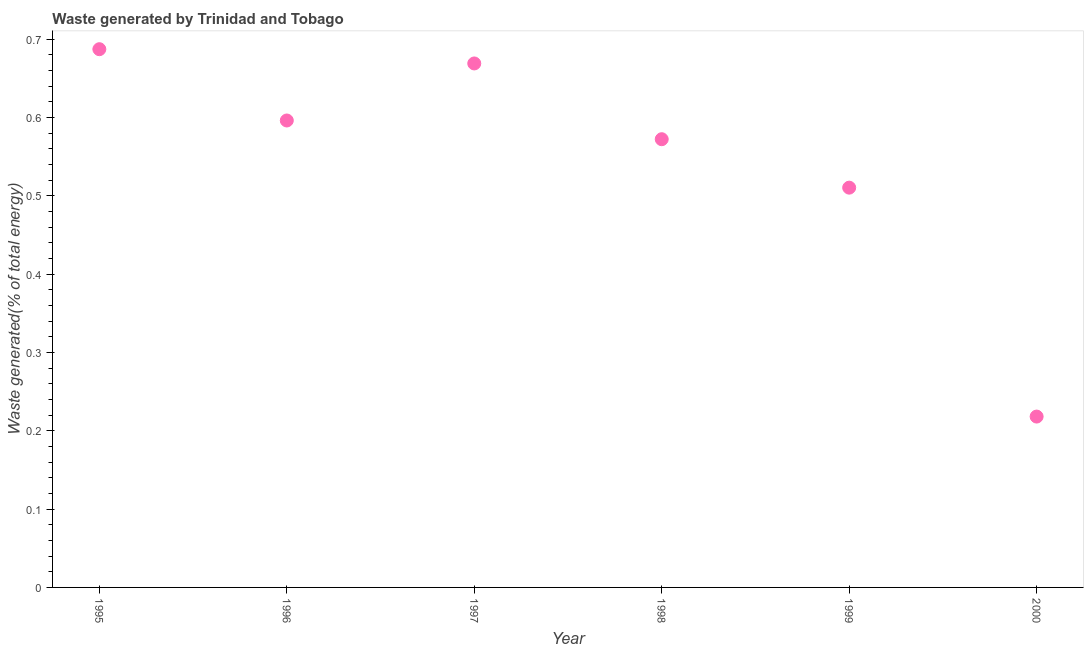What is the amount of waste generated in 1995?
Your response must be concise. 0.69. Across all years, what is the maximum amount of waste generated?
Give a very brief answer. 0.69. Across all years, what is the minimum amount of waste generated?
Your answer should be very brief. 0.22. In which year was the amount of waste generated maximum?
Your answer should be very brief. 1995. What is the sum of the amount of waste generated?
Your answer should be very brief. 3.25. What is the difference between the amount of waste generated in 1995 and 1999?
Offer a terse response. 0.18. What is the average amount of waste generated per year?
Ensure brevity in your answer.  0.54. What is the median amount of waste generated?
Give a very brief answer. 0.58. In how many years, is the amount of waste generated greater than 0.14 %?
Ensure brevity in your answer.  6. Do a majority of the years between 1999 and 2000 (inclusive) have amount of waste generated greater than 0.38000000000000006 %?
Provide a short and direct response. No. What is the ratio of the amount of waste generated in 1998 to that in 2000?
Your answer should be compact. 2.62. Is the amount of waste generated in 1996 less than that in 1997?
Give a very brief answer. Yes. Is the difference between the amount of waste generated in 1996 and 2000 greater than the difference between any two years?
Ensure brevity in your answer.  No. What is the difference between the highest and the second highest amount of waste generated?
Offer a very short reply. 0.02. Is the sum of the amount of waste generated in 1995 and 1999 greater than the maximum amount of waste generated across all years?
Give a very brief answer. Yes. What is the difference between the highest and the lowest amount of waste generated?
Offer a terse response. 0.47. Does the amount of waste generated monotonically increase over the years?
Offer a very short reply. No. How many dotlines are there?
Your answer should be very brief. 1. What is the difference between two consecutive major ticks on the Y-axis?
Give a very brief answer. 0.1. Are the values on the major ticks of Y-axis written in scientific E-notation?
Your response must be concise. No. Does the graph contain grids?
Your response must be concise. No. What is the title of the graph?
Make the answer very short. Waste generated by Trinidad and Tobago. What is the label or title of the X-axis?
Keep it short and to the point. Year. What is the label or title of the Y-axis?
Keep it short and to the point. Waste generated(% of total energy). What is the Waste generated(% of total energy) in 1995?
Keep it short and to the point. 0.69. What is the Waste generated(% of total energy) in 1996?
Ensure brevity in your answer.  0.6. What is the Waste generated(% of total energy) in 1997?
Ensure brevity in your answer.  0.67. What is the Waste generated(% of total energy) in 1998?
Ensure brevity in your answer.  0.57. What is the Waste generated(% of total energy) in 1999?
Offer a terse response. 0.51. What is the Waste generated(% of total energy) in 2000?
Provide a short and direct response. 0.22. What is the difference between the Waste generated(% of total energy) in 1995 and 1996?
Your response must be concise. 0.09. What is the difference between the Waste generated(% of total energy) in 1995 and 1997?
Provide a short and direct response. 0.02. What is the difference between the Waste generated(% of total energy) in 1995 and 1998?
Provide a succinct answer. 0.11. What is the difference between the Waste generated(% of total energy) in 1995 and 1999?
Your answer should be very brief. 0.18. What is the difference between the Waste generated(% of total energy) in 1995 and 2000?
Your response must be concise. 0.47. What is the difference between the Waste generated(% of total energy) in 1996 and 1997?
Offer a very short reply. -0.07. What is the difference between the Waste generated(% of total energy) in 1996 and 1998?
Your answer should be compact. 0.02. What is the difference between the Waste generated(% of total energy) in 1996 and 1999?
Give a very brief answer. 0.09. What is the difference between the Waste generated(% of total energy) in 1996 and 2000?
Give a very brief answer. 0.38. What is the difference between the Waste generated(% of total energy) in 1997 and 1998?
Keep it short and to the point. 0.1. What is the difference between the Waste generated(% of total energy) in 1997 and 1999?
Ensure brevity in your answer.  0.16. What is the difference between the Waste generated(% of total energy) in 1997 and 2000?
Give a very brief answer. 0.45. What is the difference between the Waste generated(% of total energy) in 1998 and 1999?
Offer a very short reply. 0.06. What is the difference between the Waste generated(% of total energy) in 1998 and 2000?
Your answer should be very brief. 0.35. What is the difference between the Waste generated(% of total energy) in 1999 and 2000?
Keep it short and to the point. 0.29. What is the ratio of the Waste generated(% of total energy) in 1995 to that in 1996?
Keep it short and to the point. 1.15. What is the ratio of the Waste generated(% of total energy) in 1995 to that in 1998?
Provide a short and direct response. 1.2. What is the ratio of the Waste generated(% of total energy) in 1995 to that in 1999?
Provide a succinct answer. 1.35. What is the ratio of the Waste generated(% of total energy) in 1995 to that in 2000?
Offer a very short reply. 3.15. What is the ratio of the Waste generated(% of total energy) in 1996 to that in 1997?
Provide a succinct answer. 0.89. What is the ratio of the Waste generated(% of total energy) in 1996 to that in 1998?
Your answer should be compact. 1.04. What is the ratio of the Waste generated(% of total energy) in 1996 to that in 1999?
Provide a short and direct response. 1.17. What is the ratio of the Waste generated(% of total energy) in 1996 to that in 2000?
Give a very brief answer. 2.73. What is the ratio of the Waste generated(% of total energy) in 1997 to that in 1998?
Keep it short and to the point. 1.17. What is the ratio of the Waste generated(% of total energy) in 1997 to that in 1999?
Provide a short and direct response. 1.31. What is the ratio of the Waste generated(% of total energy) in 1997 to that in 2000?
Ensure brevity in your answer.  3.07. What is the ratio of the Waste generated(% of total energy) in 1998 to that in 1999?
Provide a succinct answer. 1.12. What is the ratio of the Waste generated(% of total energy) in 1998 to that in 2000?
Your answer should be very brief. 2.62. What is the ratio of the Waste generated(% of total energy) in 1999 to that in 2000?
Provide a short and direct response. 2.34. 